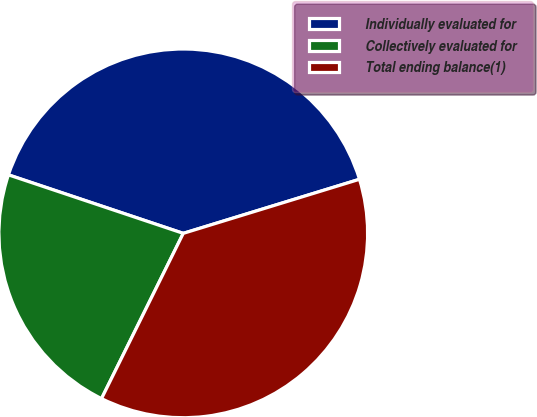<chart> <loc_0><loc_0><loc_500><loc_500><pie_chart><fcel>Individually evaluated for<fcel>Collectively evaluated for<fcel>Total ending balance(1)<nl><fcel>40.12%<fcel>22.83%<fcel>37.05%<nl></chart> 